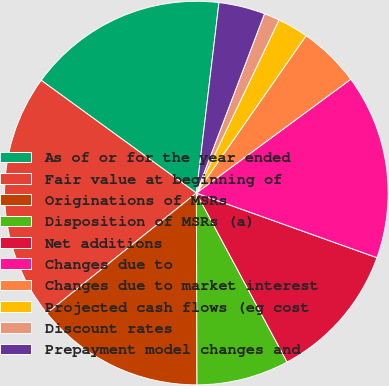Convert chart to OTSL. <chart><loc_0><loc_0><loc_500><loc_500><pie_chart><fcel>As of or for the year ended<fcel>Fair value at beginning of<fcel>Originations of MSRs<fcel>Disposition of MSRs (a)<fcel>Net additions<fcel>Changes due to<fcel>Changes due to market interest<fcel>Projected cash flows (eg cost<fcel>Discount rates<fcel>Prepayment model changes and<nl><fcel>16.88%<fcel>20.77%<fcel>14.28%<fcel>7.79%<fcel>11.69%<fcel>15.58%<fcel>5.2%<fcel>2.6%<fcel>1.31%<fcel>3.9%<nl></chart> 